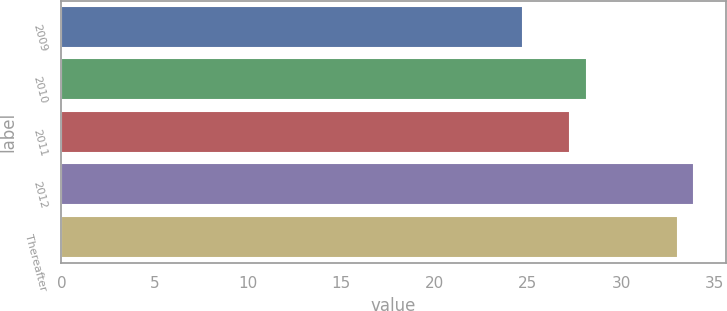<chart> <loc_0><loc_0><loc_500><loc_500><bar_chart><fcel>2009<fcel>2010<fcel>2011<fcel>2012<fcel>Thereafter<nl><fcel>24.75<fcel>28.16<fcel>27.28<fcel>33.93<fcel>33.05<nl></chart> 